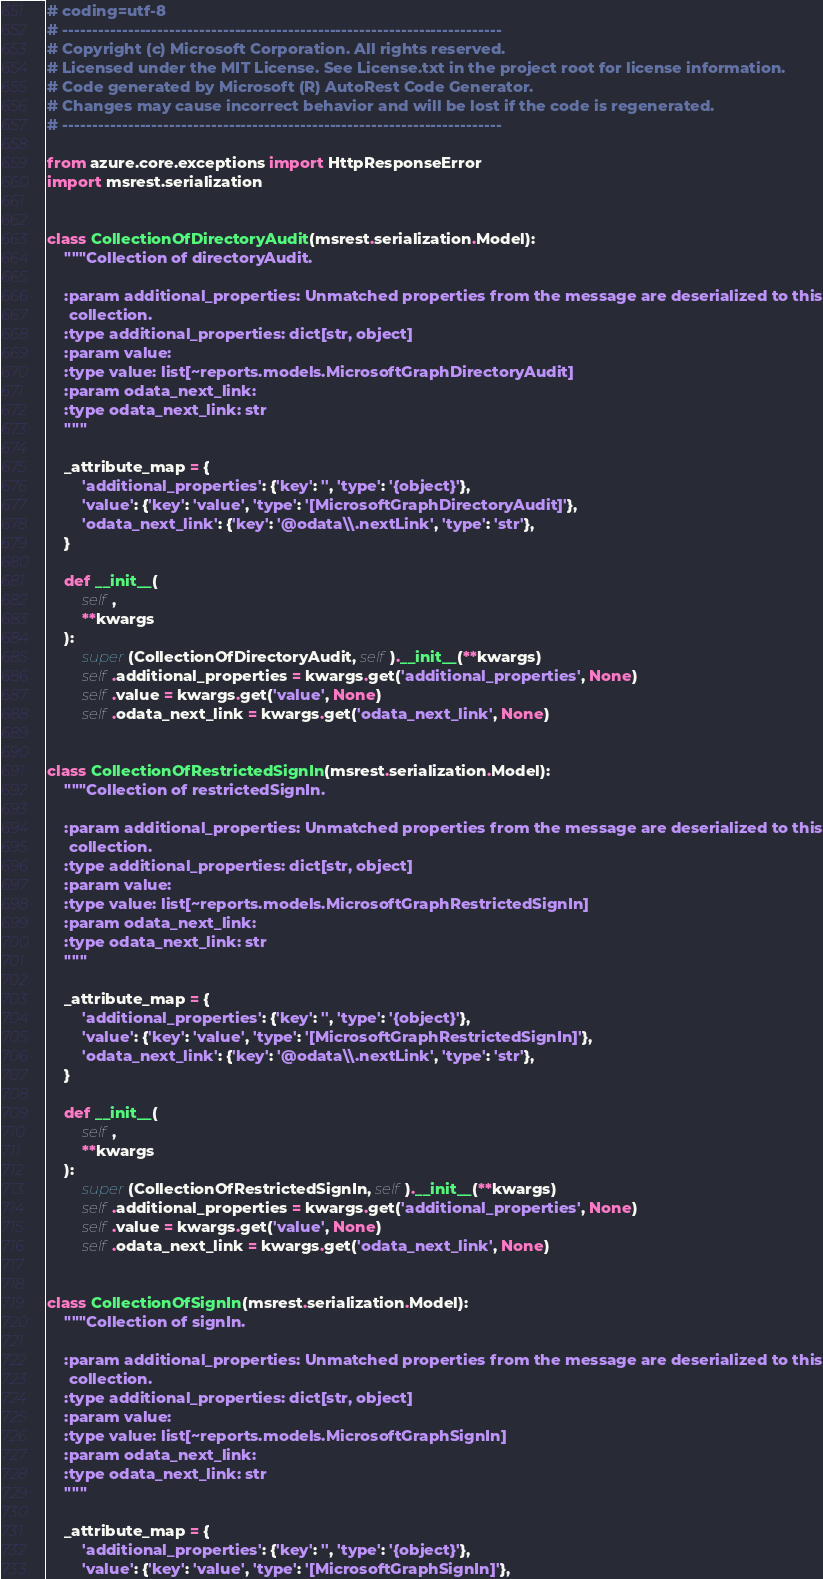<code> <loc_0><loc_0><loc_500><loc_500><_Python_># coding=utf-8
# --------------------------------------------------------------------------
# Copyright (c) Microsoft Corporation. All rights reserved.
# Licensed under the MIT License. See License.txt in the project root for license information.
# Code generated by Microsoft (R) AutoRest Code Generator.
# Changes may cause incorrect behavior and will be lost if the code is regenerated.
# --------------------------------------------------------------------------

from azure.core.exceptions import HttpResponseError
import msrest.serialization


class CollectionOfDirectoryAudit(msrest.serialization.Model):
    """Collection of directoryAudit.

    :param additional_properties: Unmatched properties from the message are deserialized to this
     collection.
    :type additional_properties: dict[str, object]
    :param value:
    :type value: list[~reports.models.MicrosoftGraphDirectoryAudit]
    :param odata_next_link:
    :type odata_next_link: str
    """

    _attribute_map = {
        'additional_properties': {'key': '', 'type': '{object}'},
        'value': {'key': 'value', 'type': '[MicrosoftGraphDirectoryAudit]'},
        'odata_next_link': {'key': '@odata\\.nextLink', 'type': 'str'},
    }

    def __init__(
        self,
        **kwargs
    ):
        super(CollectionOfDirectoryAudit, self).__init__(**kwargs)
        self.additional_properties = kwargs.get('additional_properties', None)
        self.value = kwargs.get('value', None)
        self.odata_next_link = kwargs.get('odata_next_link', None)


class CollectionOfRestrictedSignIn(msrest.serialization.Model):
    """Collection of restrictedSignIn.

    :param additional_properties: Unmatched properties from the message are deserialized to this
     collection.
    :type additional_properties: dict[str, object]
    :param value:
    :type value: list[~reports.models.MicrosoftGraphRestrictedSignIn]
    :param odata_next_link:
    :type odata_next_link: str
    """

    _attribute_map = {
        'additional_properties': {'key': '', 'type': '{object}'},
        'value': {'key': 'value', 'type': '[MicrosoftGraphRestrictedSignIn]'},
        'odata_next_link': {'key': '@odata\\.nextLink', 'type': 'str'},
    }

    def __init__(
        self,
        **kwargs
    ):
        super(CollectionOfRestrictedSignIn, self).__init__(**kwargs)
        self.additional_properties = kwargs.get('additional_properties', None)
        self.value = kwargs.get('value', None)
        self.odata_next_link = kwargs.get('odata_next_link', None)


class CollectionOfSignIn(msrest.serialization.Model):
    """Collection of signIn.

    :param additional_properties: Unmatched properties from the message are deserialized to this
     collection.
    :type additional_properties: dict[str, object]
    :param value:
    :type value: list[~reports.models.MicrosoftGraphSignIn]
    :param odata_next_link:
    :type odata_next_link: str
    """

    _attribute_map = {
        'additional_properties': {'key': '', 'type': '{object}'},
        'value': {'key': 'value', 'type': '[MicrosoftGraphSignIn]'},</code> 